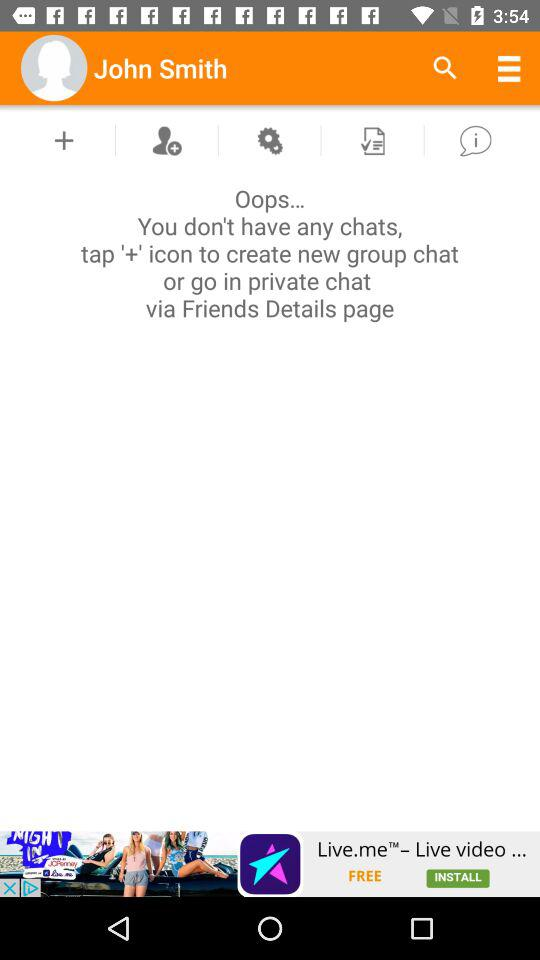What is the user name? The user name is John Smith. 